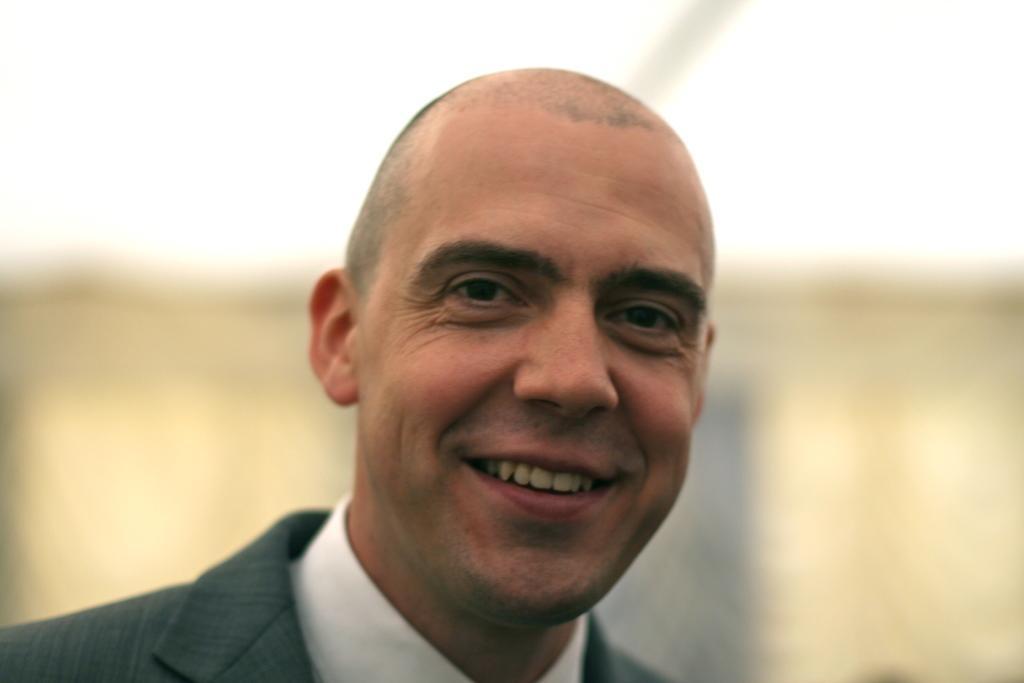What is the main subject in the foreground of the image? There is a person in the foreground of the image. What is the person doing in the image? The person is smiling. Can you describe the background of the image? The background of the image is blurred. How many planes can be seen flying in the background of the image? There are no planes visible in the image; the background is blurred. What type of spiders are crawling on the person's collar in the image? There are no spiders present in the image, and the person is not wearing a collar. 